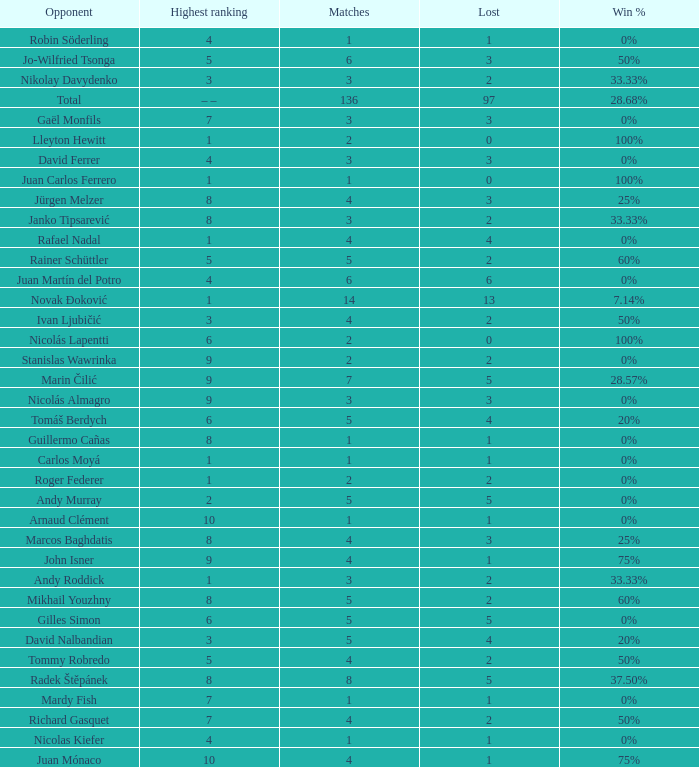Give me the full table as a dictionary. {'header': ['Opponent', 'Highest ranking', 'Matches', 'Lost', 'Win %'], 'rows': [['Robin Söderling', '4', '1', '1', '0%'], ['Jo-Wilfried Tsonga', '5', '6', '3', '50%'], ['Nikolay Davydenko', '3', '3', '2', '33.33%'], ['Total', '– –', '136', '97', '28.68%'], ['Gaël Monfils', '7', '3', '3', '0%'], ['Lleyton Hewitt', '1', '2', '0', '100%'], ['David Ferrer', '4', '3', '3', '0%'], ['Juan Carlos Ferrero', '1', '1', '0', '100%'], ['Jürgen Melzer', '8', '4', '3', '25%'], ['Janko Tipsarević', '8', '3', '2', '33.33%'], ['Rafael Nadal', '1', '4', '4', '0%'], ['Rainer Schüttler', '5', '5', '2', '60%'], ['Juan Martín del Potro', '4', '6', '6', '0%'], ['Novak Đoković', '1', '14', '13', '7.14%'], ['Ivan Ljubičić', '3', '4', '2', '50%'], ['Nicolás Lapentti', '6', '2', '0', '100%'], ['Stanislas Wawrinka', '9', '2', '2', '0%'], ['Marin Čilić', '9', '7', '5', '28.57%'], ['Nicolás Almagro', '9', '3', '3', '0%'], ['Tomáš Berdych', '6', '5', '4', '20%'], ['Guillermo Cañas', '8', '1', '1', '0%'], ['Carlos Moyá', '1', '1', '1', '0%'], ['Roger Federer', '1', '2', '2', '0%'], ['Andy Murray', '2', '5', '5', '0%'], ['Arnaud Clément', '10', '1', '1', '0%'], ['Marcos Baghdatis', '8', '4', '3', '25%'], ['John Isner', '9', '4', '1', '75%'], ['Andy Roddick', '1', '3', '2', '33.33%'], ['Mikhail Youzhny', '8', '5', '2', '60%'], ['Gilles Simon', '6', '5', '5', '0%'], ['David Nalbandian', '3', '5', '4', '20%'], ['Tommy Robredo', '5', '4', '2', '50%'], ['Radek Štěpánek', '8', '8', '5', '37.50%'], ['Mardy Fish', '7', '1', '1', '0%'], ['Richard Gasquet', '7', '4', '2', '50%'], ['Nicolas Kiefer', '4', '1', '1', '0%'], ['Juan Mónaco', '10', '4', '1', '75%']]} What is the largest number Lost to david nalbandian with a Win Rate of 20%? 4.0. 